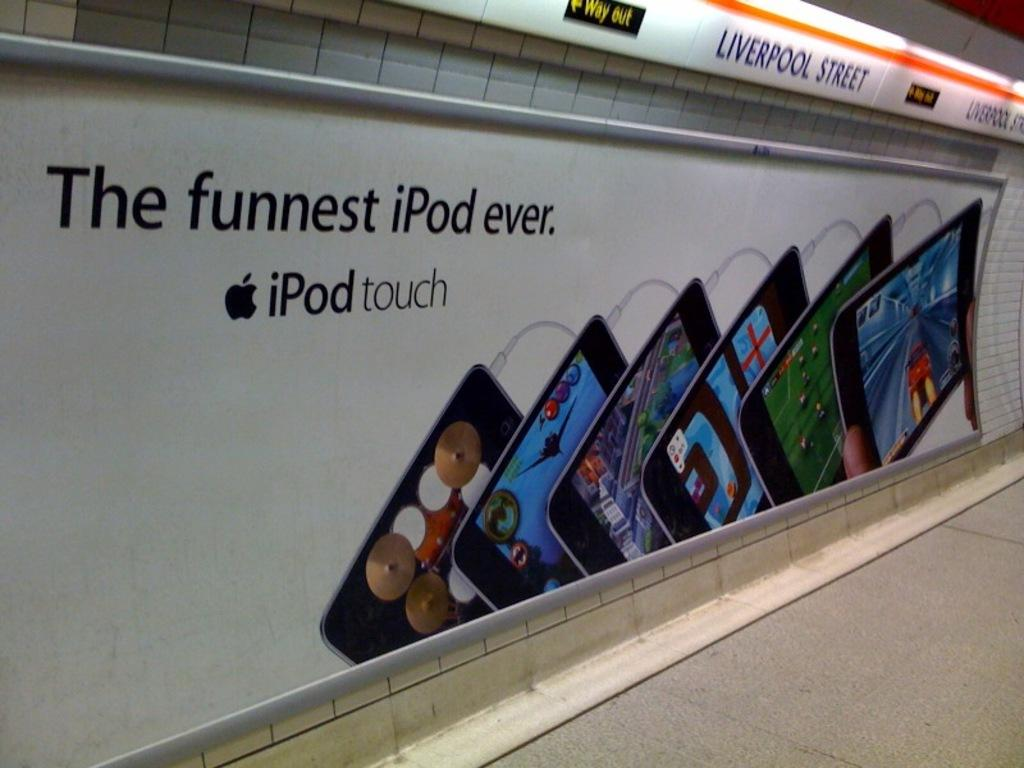Provide a one-sentence caption for the provided image. Subway ad that says "The Funnest iPod Ever". 